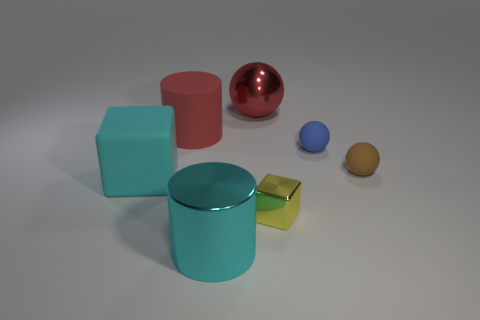Do the metallic thing behind the cyan rubber cube and the big rubber thing behind the blue ball have the same color?
Keep it short and to the point. Yes. Is there anything else that is the same color as the tiny cube?
Your answer should be very brief. No. Are there fewer big shiny spheres that are on the right side of the small brown matte thing than large shiny spheres?
Offer a terse response. Yes. How many small purple cylinders are there?
Offer a terse response. 0. Is the shape of the red shiny object the same as the small yellow thing that is in front of the big matte block?
Your answer should be very brief. No. Is the number of tiny metal objects in front of the cyan shiny cylinder less than the number of large objects left of the red cylinder?
Offer a very short reply. Yes. Is the red rubber object the same shape as the small blue matte object?
Provide a short and direct response. No. How big is the blue rubber thing?
Your response must be concise. Small. There is a large object that is behind the big cyan cylinder and on the right side of the big red rubber cylinder; what color is it?
Your response must be concise. Red. Are there more big brown metallic cylinders than red matte things?
Provide a succinct answer. No. 